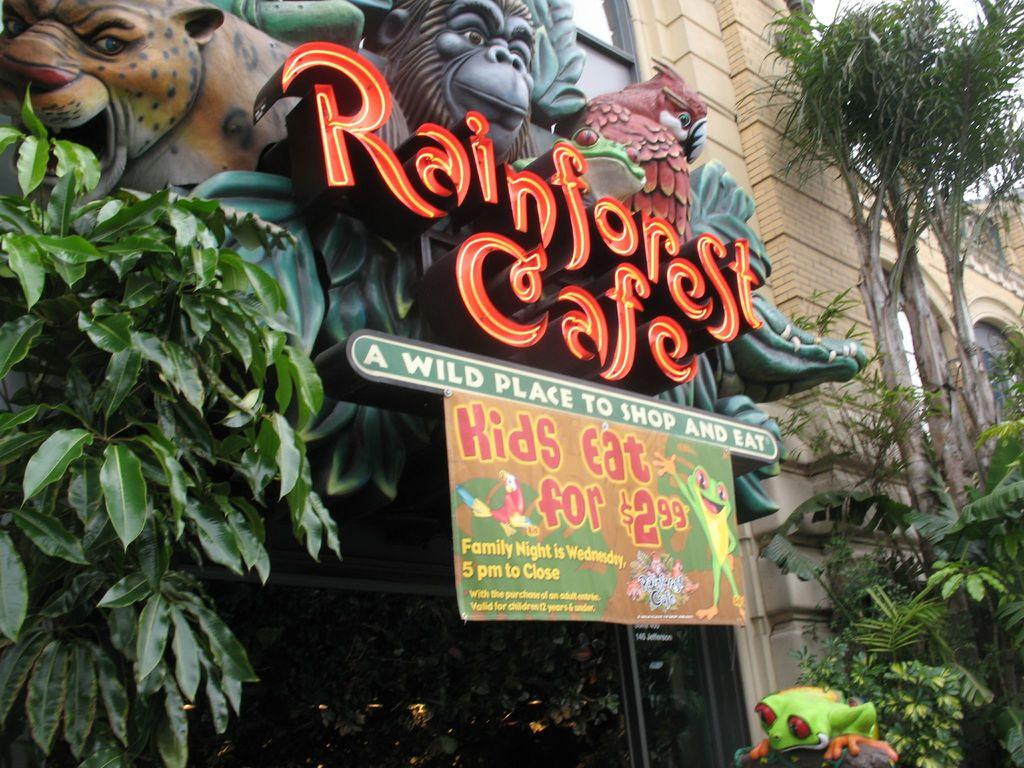What type of location is depicted in the image? The image shows an entrance to a rain forest. What can be seen at the entrance? There are animal structures and a label at the entrance. What is the purpose of the label? The label likely provides information about the rain forest or the entrance. What type of vegetation is present near the entrance? Trees are present on either side of the label. What type of agreement is being signed by the horses in the image? There are no horses present in the image, and therefore no agreement being signed. 